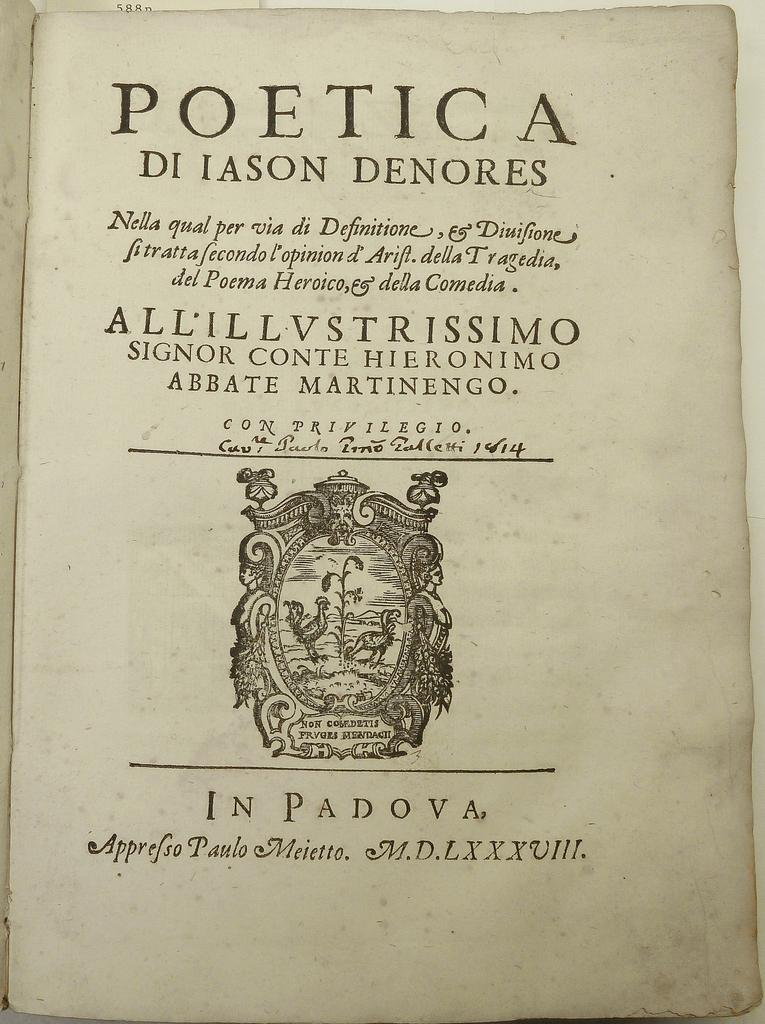<image>
Render a clear and concise summary of the photo. a page that says 'poetica di iason denores' on it 